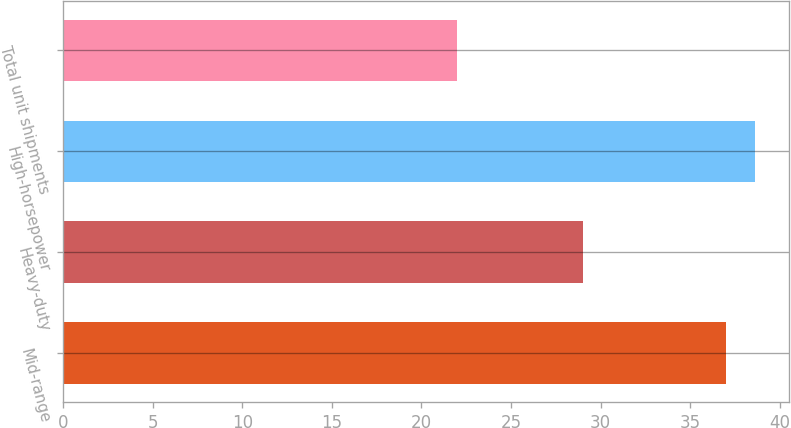Convert chart. <chart><loc_0><loc_0><loc_500><loc_500><bar_chart><fcel>Mid-range<fcel>Heavy-duty<fcel>High-horsepower<fcel>Total unit shipments<nl><fcel>37<fcel>29<fcel>38.6<fcel>22<nl></chart> 